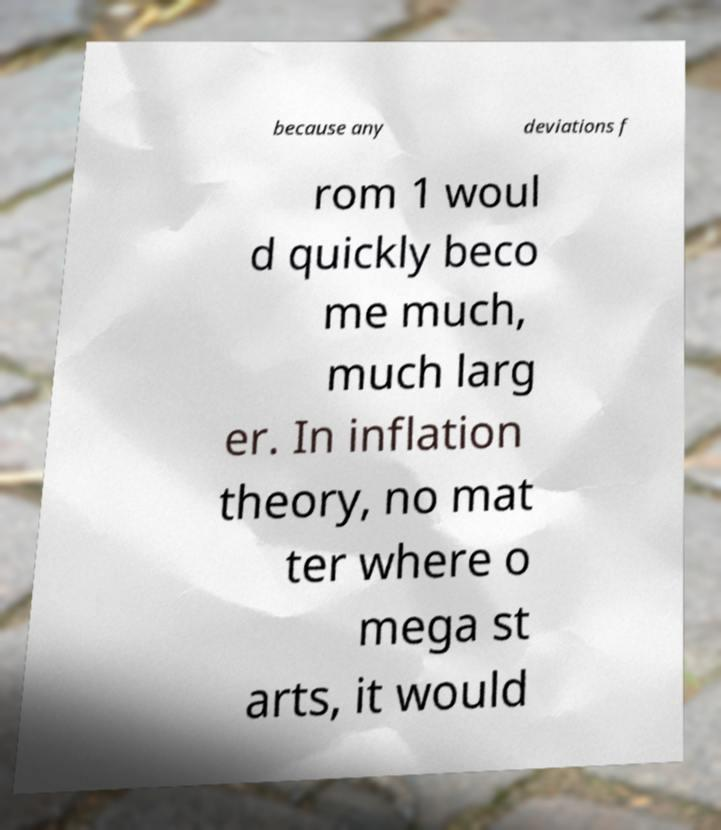Please read and relay the text visible in this image. What does it say? because any deviations f rom 1 woul d quickly beco me much, much larg er. In inflation theory, no mat ter where o mega st arts, it would 